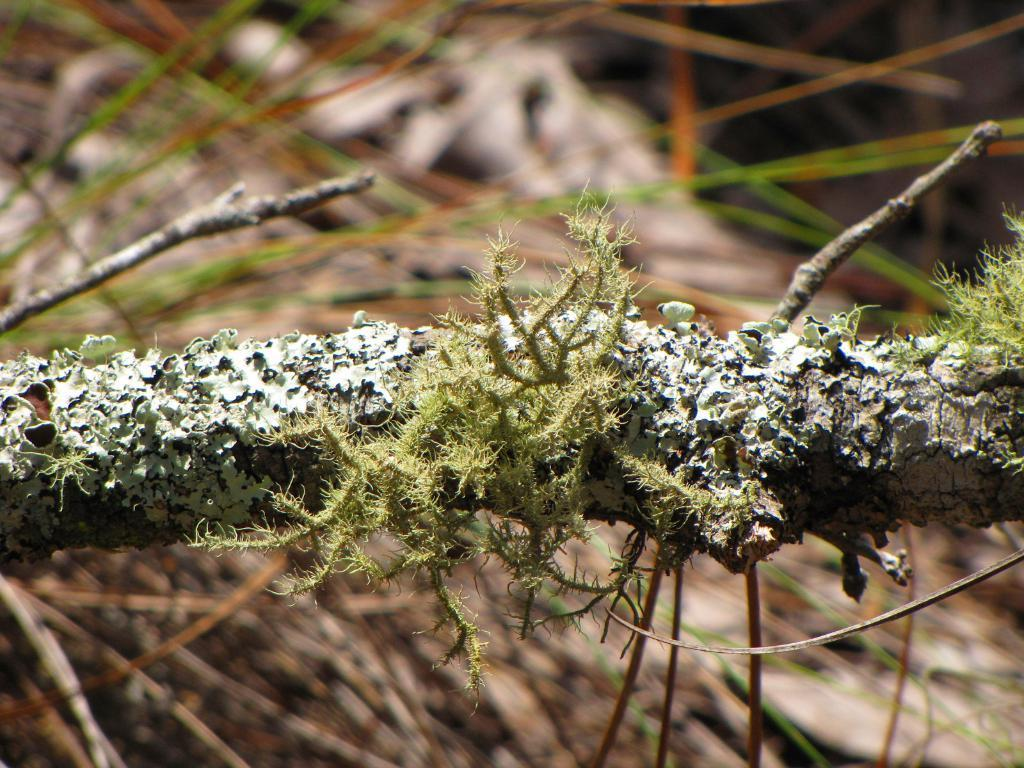What is present on the tree in the image? There is a branch of a tree in the image. What can be seen on the branch in the image? There is algae on the branch in the image. What type of bear can be seen climbing the tree in the image? There is no bear present in the image; it only features a branch with algae. What kind of pest is visible on the branch in the image? There is no pest visible on the branch in the image; it only features algae. 